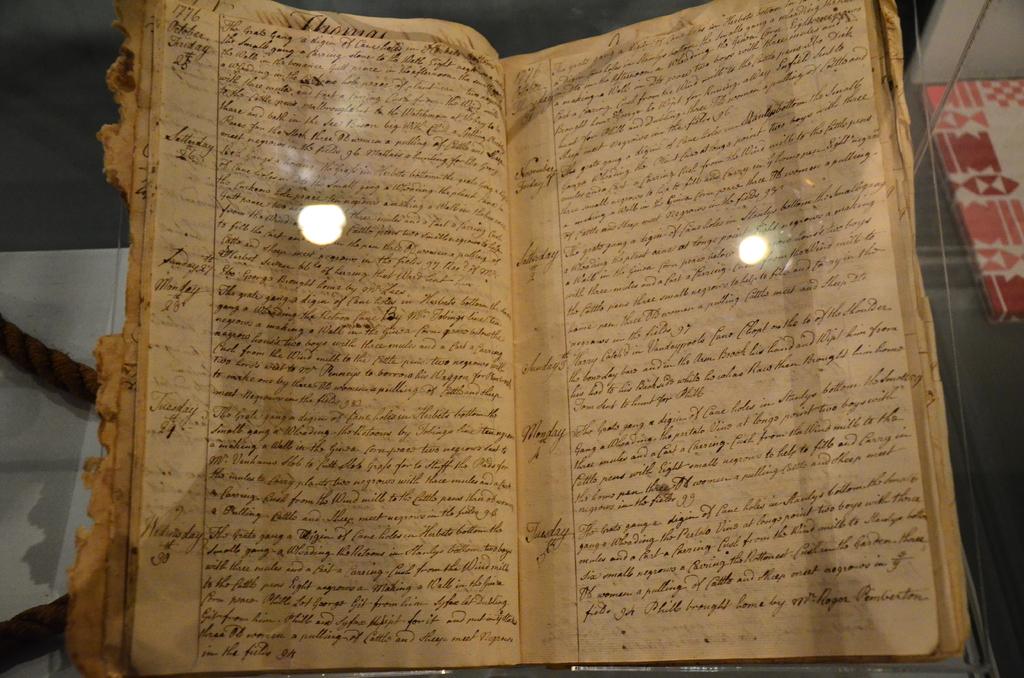Is this an old book?
Offer a very short reply. Yes. 